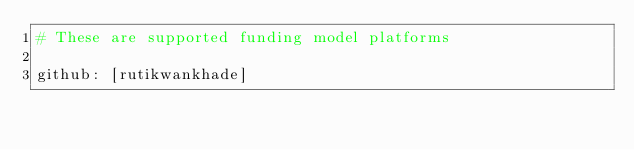<code> <loc_0><loc_0><loc_500><loc_500><_YAML_># These are supported funding model platforms

github: [rutikwankhade]
</code> 